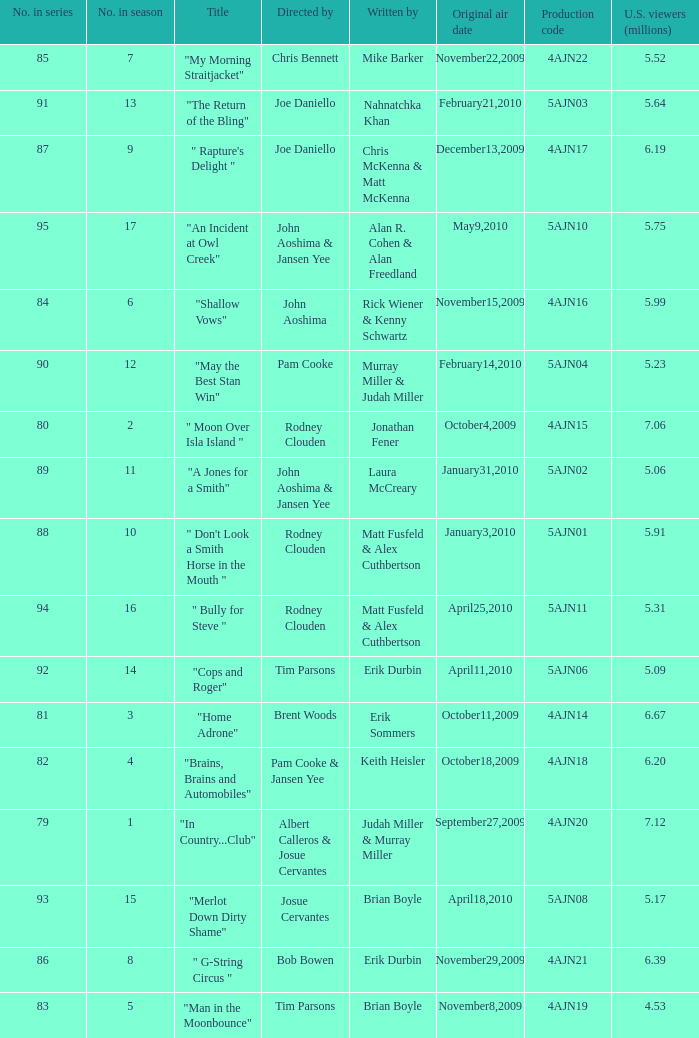Name who wrote 5ajn11 Matt Fusfeld & Alex Cuthbertson. 